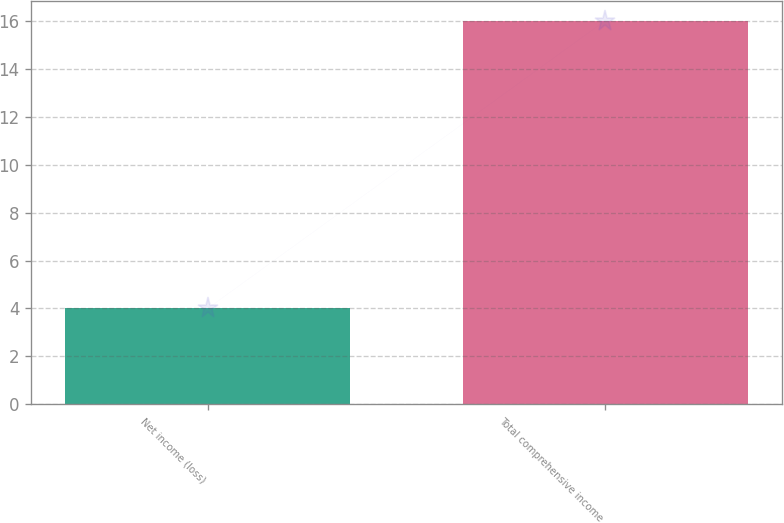<chart> <loc_0><loc_0><loc_500><loc_500><bar_chart><fcel>Net income (loss)<fcel>Total comprehensive income<nl><fcel>4<fcel>16<nl></chart> 